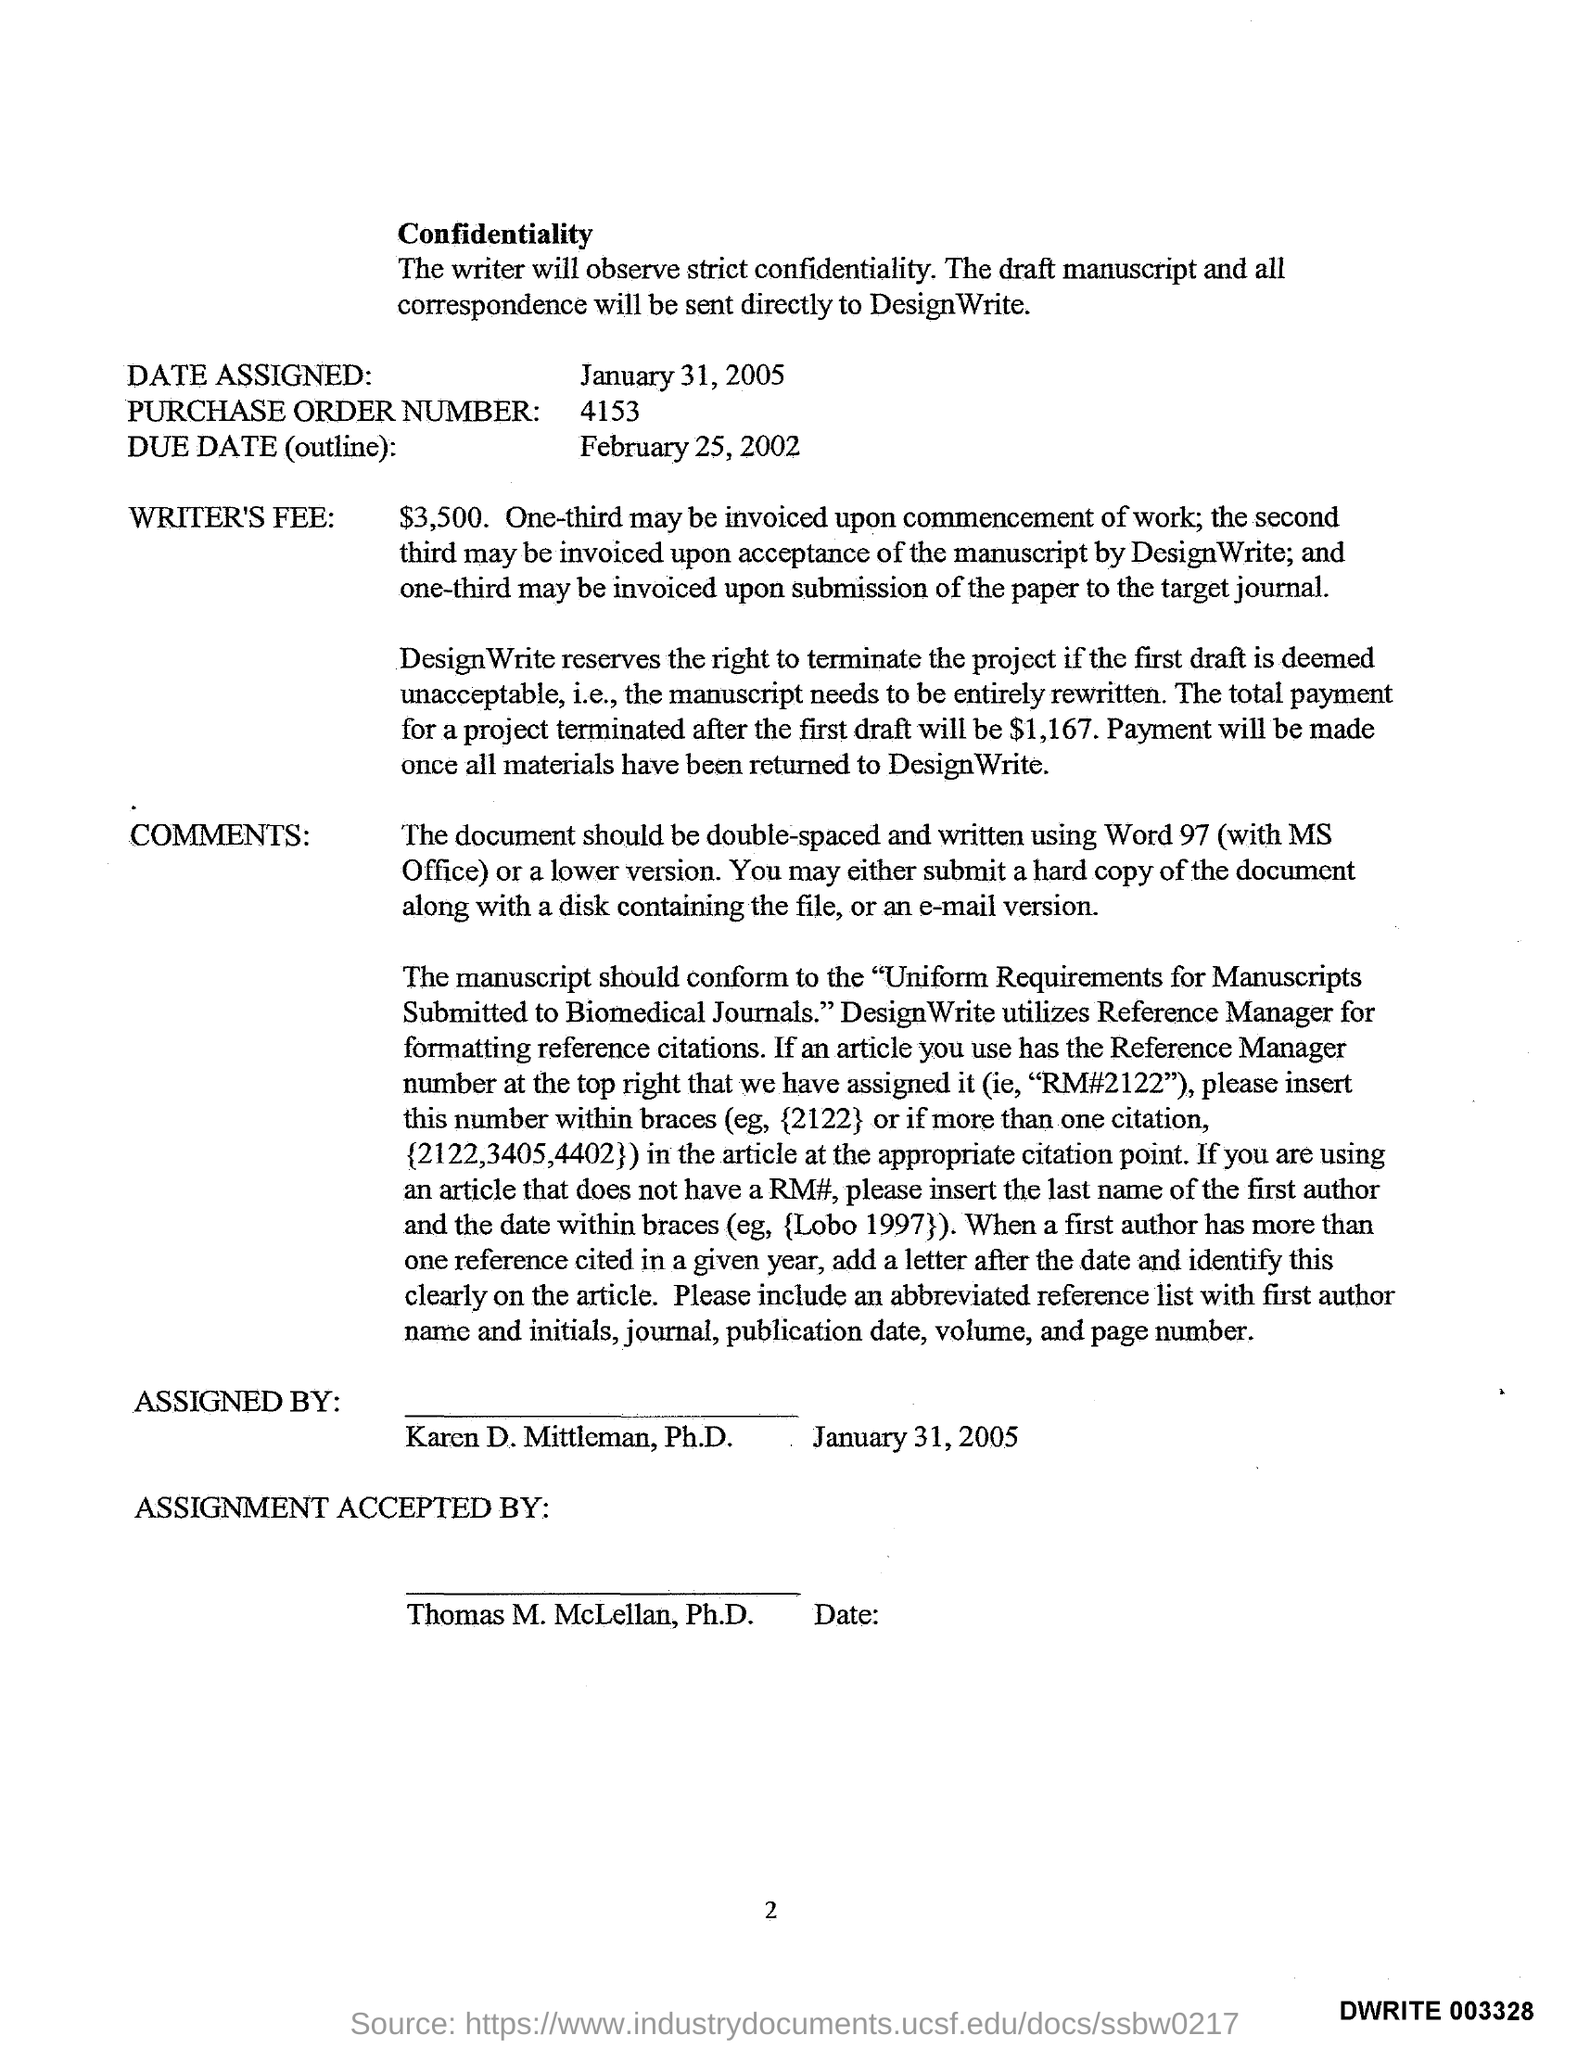Highlight a few significant elements in this photo. The purchase order number is 4153. The due date for the outline is February 25, 2002. 